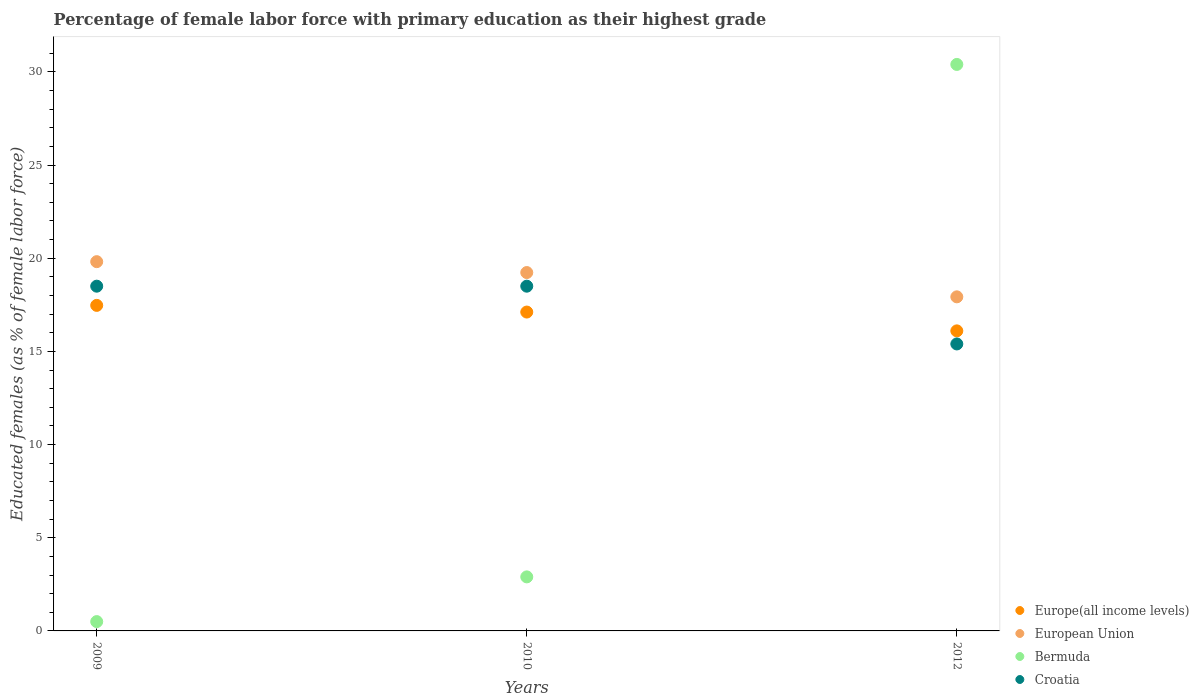How many different coloured dotlines are there?
Provide a short and direct response. 4. Across all years, what is the maximum percentage of female labor force with primary education in European Union?
Give a very brief answer. 19.82. Across all years, what is the minimum percentage of female labor force with primary education in Croatia?
Your response must be concise. 15.4. In which year was the percentage of female labor force with primary education in European Union maximum?
Provide a short and direct response. 2009. What is the total percentage of female labor force with primary education in Bermuda in the graph?
Give a very brief answer. 33.8. What is the difference between the percentage of female labor force with primary education in Bermuda in 2009 and that in 2012?
Offer a terse response. -29.9. What is the difference between the percentage of female labor force with primary education in European Union in 2010 and the percentage of female labor force with primary education in Europe(all income levels) in 2012?
Provide a succinct answer. 3.13. What is the average percentage of female labor force with primary education in Croatia per year?
Provide a succinct answer. 17.47. In the year 2009, what is the difference between the percentage of female labor force with primary education in Europe(all income levels) and percentage of female labor force with primary education in Croatia?
Your answer should be compact. -1.03. In how many years, is the percentage of female labor force with primary education in Bermuda greater than 11 %?
Make the answer very short. 1. What is the ratio of the percentage of female labor force with primary education in Europe(all income levels) in 2009 to that in 2012?
Provide a succinct answer. 1.08. What is the difference between the highest and the second highest percentage of female labor force with primary education in Europe(all income levels)?
Make the answer very short. 0.36. What is the difference between the highest and the lowest percentage of female labor force with primary education in European Union?
Your answer should be compact. 1.89. Is the percentage of female labor force with primary education in Croatia strictly greater than the percentage of female labor force with primary education in European Union over the years?
Provide a succinct answer. No. Is the percentage of female labor force with primary education in European Union strictly less than the percentage of female labor force with primary education in Bermuda over the years?
Your answer should be very brief. No. What is the difference between two consecutive major ticks on the Y-axis?
Keep it short and to the point. 5. Are the values on the major ticks of Y-axis written in scientific E-notation?
Your response must be concise. No. Does the graph contain any zero values?
Offer a terse response. No. Does the graph contain grids?
Provide a succinct answer. No. Where does the legend appear in the graph?
Give a very brief answer. Bottom right. How are the legend labels stacked?
Your response must be concise. Vertical. What is the title of the graph?
Offer a terse response. Percentage of female labor force with primary education as their highest grade. What is the label or title of the X-axis?
Ensure brevity in your answer.  Years. What is the label or title of the Y-axis?
Provide a succinct answer. Educated females (as % of female labor force). What is the Educated females (as % of female labor force) in Europe(all income levels) in 2009?
Your answer should be very brief. 17.47. What is the Educated females (as % of female labor force) in European Union in 2009?
Give a very brief answer. 19.82. What is the Educated females (as % of female labor force) in Europe(all income levels) in 2010?
Your answer should be compact. 17.11. What is the Educated females (as % of female labor force) of European Union in 2010?
Provide a short and direct response. 19.23. What is the Educated females (as % of female labor force) of Bermuda in 2010?
Give a very brief answer. 2.9. What is the Educated females (as % of female labor force) in Europe(all income levels) in 2012?
Give a very brief answer. 16.1. What is the Educated females (as % of female labor force) in European Union in 2012?
Your answer should be very brief. 17.93. What is the Educated females (as % of female labor force) in Bermuda in 2012?
Provide a succinct answer. 30.4. What is the Educated females (as % of female labor force) in Croatia in 2012?
Provide a succinct answer. 15.4. Across all years, what is the maximum Educated females (as % of female labor force) in Europe(all income levels)?
Your answer should be very brief. 17.47. Across all years, what is the maximum Educated females (as % of female labor force) of European Union?
Your response must be concise. 19.82. Across all years, what is the maximum Educated females (as % of female labor force) of Bermuda?
Your response must be concise. 30.4. Across all years, what is the maximum Educated females (as % of female labor force) in Croatia?
Give a very brief answer. 18.5. Across all years, what is the minimum Educated females (as % of female labor force) of Europe(all income levels)?
Your answer should be compact. 16.1. Across all years, what is the minimum Educated females (as % of female labor force) of European Union?
Your answer should be compact. 17.93. Across all years, what is the minimum Educated females (as % of female labor force) in Bermuda?
Your response must be concise. 0.5. Across all years, what is the minimum Educated females (as % of female labor force) in Croatia?
Give a very brief answer. 15.4. What is the total Educated females (as % of female labor force) of Europe(all income levels) in the graph?
Your response must be concise. 50.68. What is the total Educated females (as % of female labor force) of European Union in the graph?
Ensure brevity in your answer.  56.98. What is the total Educated females (as % of female labor force) in Bermuda in the graph?
Your answer should be very brief. 33.8. What is the total Educated females (as % of female labor force) of Croatia in the graph?
Make the answer very short. 52.4. What is the difference between the Educated females (as % of female labor force) of Europe(all income levels) in 2009 and that in 2010?
Your answer should be very brief. 0.36. What is the difference between the Educated females (as % of female labor force) of European Union in 2009 and that in 2010?
Make the answer very short. 0.58. What is the difference between the Educated females (as % of female labor force) in Bermuda in 2009 and that in 2010?
Your answer should be compact. -2.4. What is the difference between the Educated females (as % of female labor force) in Croatia in 2009 and that in 2010?
Ensure brevity in your answer.  0. What is the difference between the Educated females (as % of female labor force) of Europe(all income levels) in 2009 and that in 2012?
Your answer should be very brief. 1.37. What is the difference between the Educated females (as % of female labor force) of European Union in 2009 and that in 2012?
Provide a succinct answer. 1.89. What is the difference between the Educated females (as % of female labor force) in Bermuda in 2009 and that in 2012?
Provide a short and direct response. -29.9. What is the difference between the Educated females (as % of female labor force) of Europe(all income levels) in 2010 and that in 2012?
Keep it short and to the point. 1.01. What is the difference between the Educated females (as % of female labor force) of European Union in 2010 and that in 2012?
Make the answer very short. 1.3. What is the difference between the Educated females (as % of female labor force) of Bermuda in 2010 and that in 2012?
Make the answer very short. -27.5. What is the difference between the Educated females (as % of female labor force) in Europe(all income levels) in 2009 and the Educated females (as % of female labor force) in European Union in 2010?
Ensure brevity in your answer.  -1.76. What is the difference between the Educated females (as % of female labor force) of Europe(all income levels) in 2009 and the Educated females (as % of female labor force) of Bermuda in 2010?
Give a very brief answer. 14.57. What is the difference between the Educated females (as % of female labor force) of Europe(all income levels) in 2009 and the Educated females (as % of female labor force) of Croatia in 2010?
Offer a terse response. -1.03. What is the difference between the Educated females (as % of female labor force) of European Union in 2009 and the Educated females (as % of female labor force) of Bermuda in 2010?
Ensure brevity in your answer.  16.92. What is the difference between the Educated females (as % of female labor force) in European Union in 2009 and the Educated females (as % of female labor force) in Croatia in 2010?
Offer a terse response. 1.32. What is the difference between the Educated females (as % of female labor force) of Europe(all income levels) in 2009 and the Educated females (as % of female labor force) of European Union in 2012?
Give a very brief answer. -0.46. What is the difference between the Educated females (as % of female labor force) of Europe(all income levels) in 2009 and the Educated females (as % of female labor force) of Bermuda in 2012?
Give a very brief answer. -12.93. What is the difference between the Educated females (as % of female labor force) in Europe(all income levels) in 2009 and the Educated females (as % of female labor force) in Croatia in 2012?
Make the answer very short. 2.07. What is the difference between the Educated females (as % of female labor force) in European Union in 2009 and the Educated females (as % of female labor force) in Bermuda in 2012?
Your response must be concise. -10.58. What is the difference between the Educated females (as % of female labor force) in European Union in 2009 and the Educated females (as % of female labor force) in Croatia in 2012?
Make the answer very short. 4.42. What is the difference between the Educated females (as % of female labor force) of Bermuda in 2009 and the Educated females (as % of female labor force) of Croatia in 2012?
Provide a short and direct response. -14.9. What is the difference between the Educated females (as % of female labor force) in Europe(all income levels) in 2010 and the Educated females (as % of female labor force) in European Union in 2012?
Keep it short and to the point. -0.82. What is the difference between the Educated females (as % of female labor force) in Europe(all income levels) in 2010 and the Educated females (as % of female labor force) in Bermuda in 2012?
Your answer should be compact. -13.29. What is the difference between the Educated females (as % of female labor force) in Europe(all income levels) in 2010 and the Educated females (as % of female labor force) in Croatia in 2012?
Your response must be concise. 1.71. What is the difference between the Educated females (as % of female labor force) of European Union in 2010 and the Educated females (as % of female labor force) of Bermuda in 2012?
Provide a succinct answer. -11.17. What is the difference between the Educated females (as % of female labor force) in European Union in 2010 and the Educated females (as % of female labor force) in Croatia in 2012?
Your answer should be very brief. 3.83. What is the average Educated females (as % of female labor force) of Europe(all income levels) per year?
Your answer should be very brief. 16.89. What is the average Educated females (as % of female labor force) in European Union per year?
Offer a terse response. 18.99. What is the average Educated females (as % of female labor force) of Bermuda per year?
Keep it short and to the point. 11.27. What is the average Educated females (as % of female labor force) of Croatia per year?
Offer a very short reply. 17.47. In the year 2009, what is the difference between the Educated females (as % of female labor force) in Europe(all income levels) and Educated females (as % of female labor force) in European Union?
Provide a succinct answer. -2.35. In the year 2009, what is the difference between the Educated females (as % of female labor force) in Europe(all income levels) and Educated females (as % of female labor force) in Bermuda?
Offer a very short reply. 16.97. In the year 2009, what is the difference between the Educated females (as % of female labor force) in Europe(all income levels) and Educated females (as % of female labor force) in Croatia?
Keep it short and to the point. -1.03. In the year 2009, what is the difference between the Educated females (as % of female labor force) of European Union and Educated females (as % of female labor force) of Bermuda?
Provide a succinct answer. 19.32. In the year 2009, what is the difference between the Educated females (as % of female labor force) of European Union and Educated females (as % of female labor force) of Croatia?
Keep it short and to the point. 1.32. In the year 2009, what is the difference between the Educated females (as % of female labor force) of Bermuda and Educated females (as % of female labor force) of Croatia?
Your answer should be compact. -18. In the year 2010, what is the difference between the Educated females (as % of female labor force) in Europe(all income levels) and Educated females (as % of female labor force) in European Union?
Your response must be concise. -2.12. In the year 2010, what is the difference between the Educated females (as % of female labor force) in Europe(all income levels) and Educated females (as % of female labor force) in Bermuda?
Provide a short and direct response. 14.21. In the year 2010, what is the difference between the Educated females (as % of female labor force) of Europe(all income levels) and Educated females (as % of female labor force) of Croatia?
Provide a short and direct response. -1.39. In the year 2010, what is the difference between the Educated females (as % of female labor force) in European Union and Educated females (as % of female labor force) in Bermuda?
Provide a short and direct response. 16.33. In the year 2010, what is the difference between the Educated females (as % of female labor force) of European Union and Educated females (as % of female labor force) of Croatia?
Your answer should be compact. 0.73. In the year 2010, what is the difference between the Educated females (as % of female labor force) in Bermuda and Educated females (as % of female labor force) in Croatia?
Provide a succinct answer. -15.6. In the year 2012, what is the difference between the Educated females (as % of female labor force) of Europe(all income levels) and Educated females (as % of female labor force) of European Union?
Your answer should be very brief. -1.83. In the year 2012, what is the difference between the Educated females (as % of female labor force) of Europe(all income levels) and Educated females (as % of female labor force) of Bermuda?
Keep it short and to the point. -14.3. In the year 2012, what is the difference between the Educated females (as % of female labor force) in Europe(all income levels) and Educated females (as % of female labor force) in Croatia?
Offer a terse response. 0.7. In the year 2012, what is the difference between the Educated females (as % of female labor force) in European Union and Educated females (as % of female labor force) in Bermuda?
Provide a short and direct response. -12.47. In the year 2012, what is the difference between the Educated females (as % of female labor force) in European Union and Educated females (as % of female labor force) in Croatia?
Ensure brevity in your answer.  2.53. In the year 2012, what is the difference between the Educated females (as % of female labor force) in Bermuda and Educated females (as % of female labor force) in Croatia?
Your answer should be very brief. 15. What is the ratio of the Educated females (as % of female labor force) in Europe(all income levels) in 2009 to that in 2010?
Ensure brevity in your answer.  1.02. What is the ratio of the Educated females (as % of female labor force) in European Union in 2009 to that in 2010?
Give a very brief answer. 1.03. What is the ratio of the Educated females (as % of female labor force) of Bermuda in 2009 to that in 2010?
Your answer should be very brief. 0.17. What is the ratio of the Educated females (as % of female labor force) in Europe(all income levels) in 2009 to that in 2012?
Make the answer very short. 1.08. What is the ratio of the Educated females (as % of female labor force) of European Union in 2009 to that in 2012?
Give a very brief answer. 1.11. What is the ratio of the Educated females (as % of female labor force) of Bermuda in 2009 to that in 2012?
Give a very brief answer. 0.02. What is the ratio of the Educated females (as % of female labor force) in Croatia in 2009 to that in 2012?
Make the answer very short. 1.2. What is the ratio of the Educated females (as % of female labor force) in Europe(all income levels) in 2010 to that in 2012?
Offer a terse response. 1.06. What is the ratio of the Educated females (as % of female labor force) in European Union in 2010 to that in 2012?
Make the answer very short. 1.07. What is the ratio of the Educated females (as % of female labor force) in Bermuda in 2010 to that in 2012?
Ensure brevity in your answer.  0.1. What is the ratio of the Educated females (as % of female labor force) in Croatia in 2010 to that in 2012?
Keep it short and to the point. 1.2. What is the difference between the highest and the second highest Educated females (as % of female labor force) of Europe(all income levels)?
Give a very brief answer. 0.36. What is the difference between the highest and the second highest Educated females (as % of female labor force) in European Union?
Your response must be concise. 0.58. What is the difference between the highest and the lowest Educated females (as % of female labor force) of Europe(all income levels)?
Give a very brief answer. 1.37. What is the difference between the highest and the lowest Educated females (as % of female labor force) of European Union?
Provide a succinct answer. 1.89. What is the difference between the highest and the lowest Educated females (as % of female labor force) in Bermuda?
Provide a short and direct response. 29.9. 